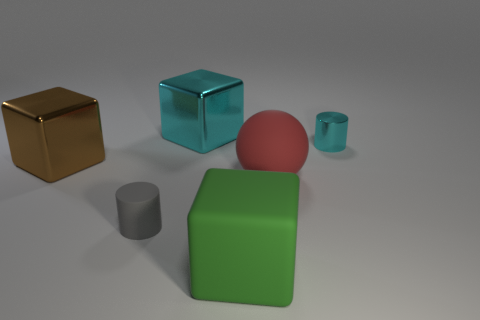Subtract all big green cubes. How many cubes are left? 2 Add 2 small gray matte objects. How many objects exist? 8 Subtract 2 cylinders. How many cylinders are left? 0 Subtract all cyan cubes. How many cubes are left? 2 Subtract all spheres. How many objects are left? 5 Subtract all brown cubes. Subtract all cyan cylinders. How many cubes are left? 2 Subtract all gray cubes. How many purple spheres are left? 0 Subtract all big cyan matte objects. Subtract all green matte objects. How many objects are left? 5 Add 1 tiny metal objects. How many tiny metal objects are left? 2 Add 6 blue shiny blocks. How many blue shiny blocks exist? 6 